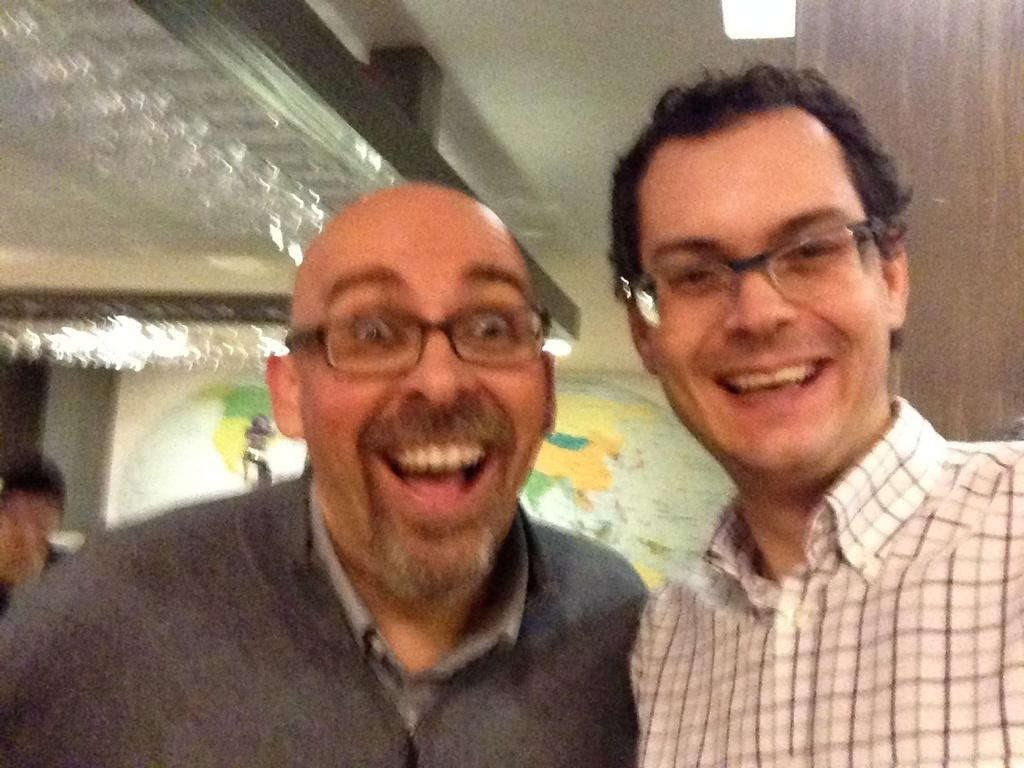How many people are in the image? There are three persons in the image. What can be seen on the wall in the image? There is a map on the wall in the image. Can you describe the light visible in the image? Yes, there is a light visible in the image. What type of rail can be seen running through the downtown area in the image? There is no rail or downtown area present in the image. What color is the feather on the person's hat in the image? There is no feather or hat present on any of the persons in the image. 